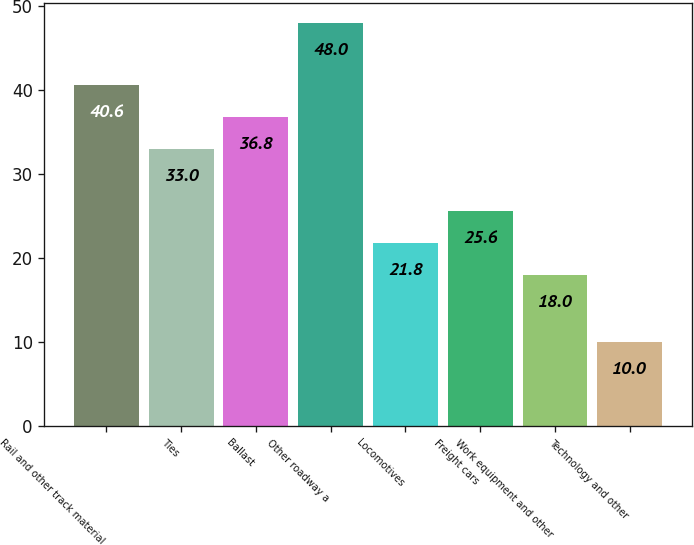Convert chart. <chart><loc_0><loc_0><loc_500><loc_500><bar_chart><fcel>Rail and other track material<fcel>Ties<fcel>Ballast<fcel>Other roadway a<fcel>Locomotives<fcel>Freight cars<fcel>Work equipment and other<fcel>Technology and other<nl><fcel>40.6<fcel>33<fcel>36.8<fcel>48<fcel>21.8<fcel>25.6<fcel>18<fcel>10<nl></chart> 